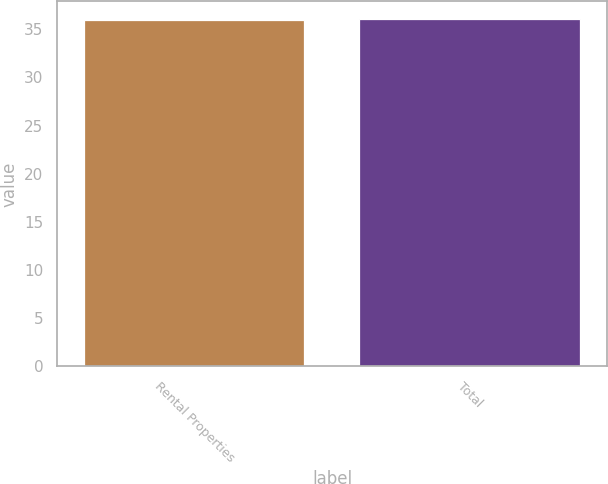Convert chart to OTSL. <chart><loc_0><loc_0><loc_500><loc_500><bar_chart><fcel>Rental Properties<fcel>Total<nl><fcel>36<fcel>36.1<nl></chart> 